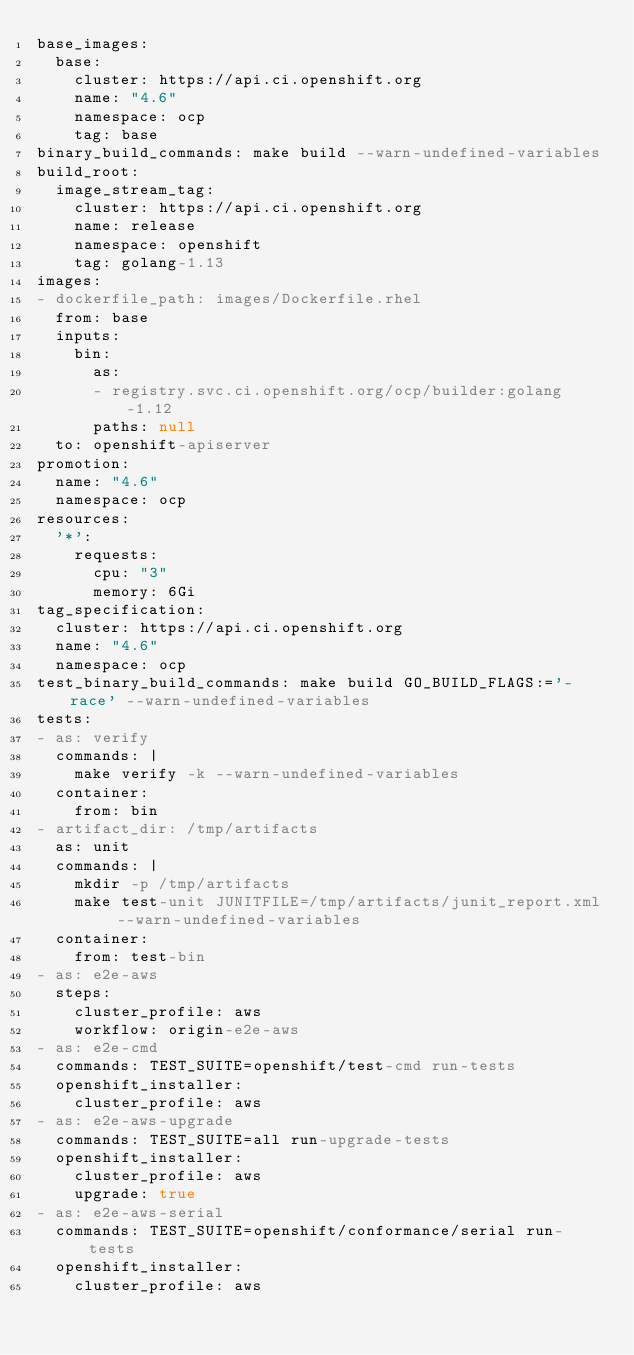<code> <loc_0><loc_0><loc_500><loc_500><_YAML_>base_images:
  base:
    cluster: https://api.ci.openshift.org
    name: "4.6"
    namespace: ocp
    tag: base
binary_build_commands: make build --warn-undefined-variables
build_root:
  image_stream_tag:
    cluster: https://api.ci.openshift.org
    name: release
    namespace: openshift
    tag: golang-1.13
images:
- dockerfile_path: images/Dockerfile.rhel
  from: base
  inputs:
    bin:
      as:
      - registry.svc.ci.openshift.org/ocp/builder:golang-1.12
      paths: null
  to: openshift-apiserver
promotion:
  name: "4.6"
  namespace: ocp
resources:
  '*':
    requests:
      cpu: "3"
      memory: 6Gi
tag_specification:
  cluster: https://api.ci.openshift.org
  name: "4.6"
  namespace: ocp
test_binary_build_commands: make build GO_BUILD_FLAGS:='-race' --warn-undefined-variables
tests:
- as: verify
  commands: |
    make verify -k --warn-undefined-variables
  container:
    from: bin
- artifact_dir: /tmp/artifacts
  as: unit
  commands: |
    mkdir -p /tmp/artifacts
    make test-unit JUNITFILE=/tmp/artifacts/junit_report.xml --warn-undefined-variables
  container:
    from: test-bin
- as: e2e-aws
  steps:
    cluster_profile: aws
    workflow: origin-e2e-aws
- as: e2e-cmd
  commands: TEST_SUITE=openshift/test-cmd run-tests
  openshift_installer:
    cluster_profile: aws
- as: e2e-aws-upgrade
  commands: TEST_SUITE=all run-upgrade-tests
  openshift_installer:
    cluster_profile: aws
    upgrade: true
- as: e2e-aws-serial
  commands: TEST_SUITE=openshift/conformance/serial run-tests
  openshift_installer:
    cluster_profile: aws
</code> 